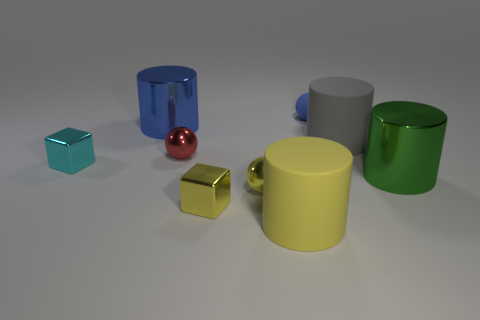Subtract all gray cylinders. How many cylinders are left? 3 Subtract 1 balls. How many balls are left? 2 Subtract all green cylinders. How many cylinders are left? 3 Subtract all purple cylinders. Subtract all red cubes. How many cylinders are left? 4 Subtract all cylinders. How many objects are left? 5 Add 4 cylinders. How many cylinders are left? 8 Add 3 big shiny things. How many big shiny things exist? 5 Subtract 1 yellow cylinders. How many objects are left? 8 Subtract all small brown shiny things. Subtract all gray things. How many objects are left? 8 